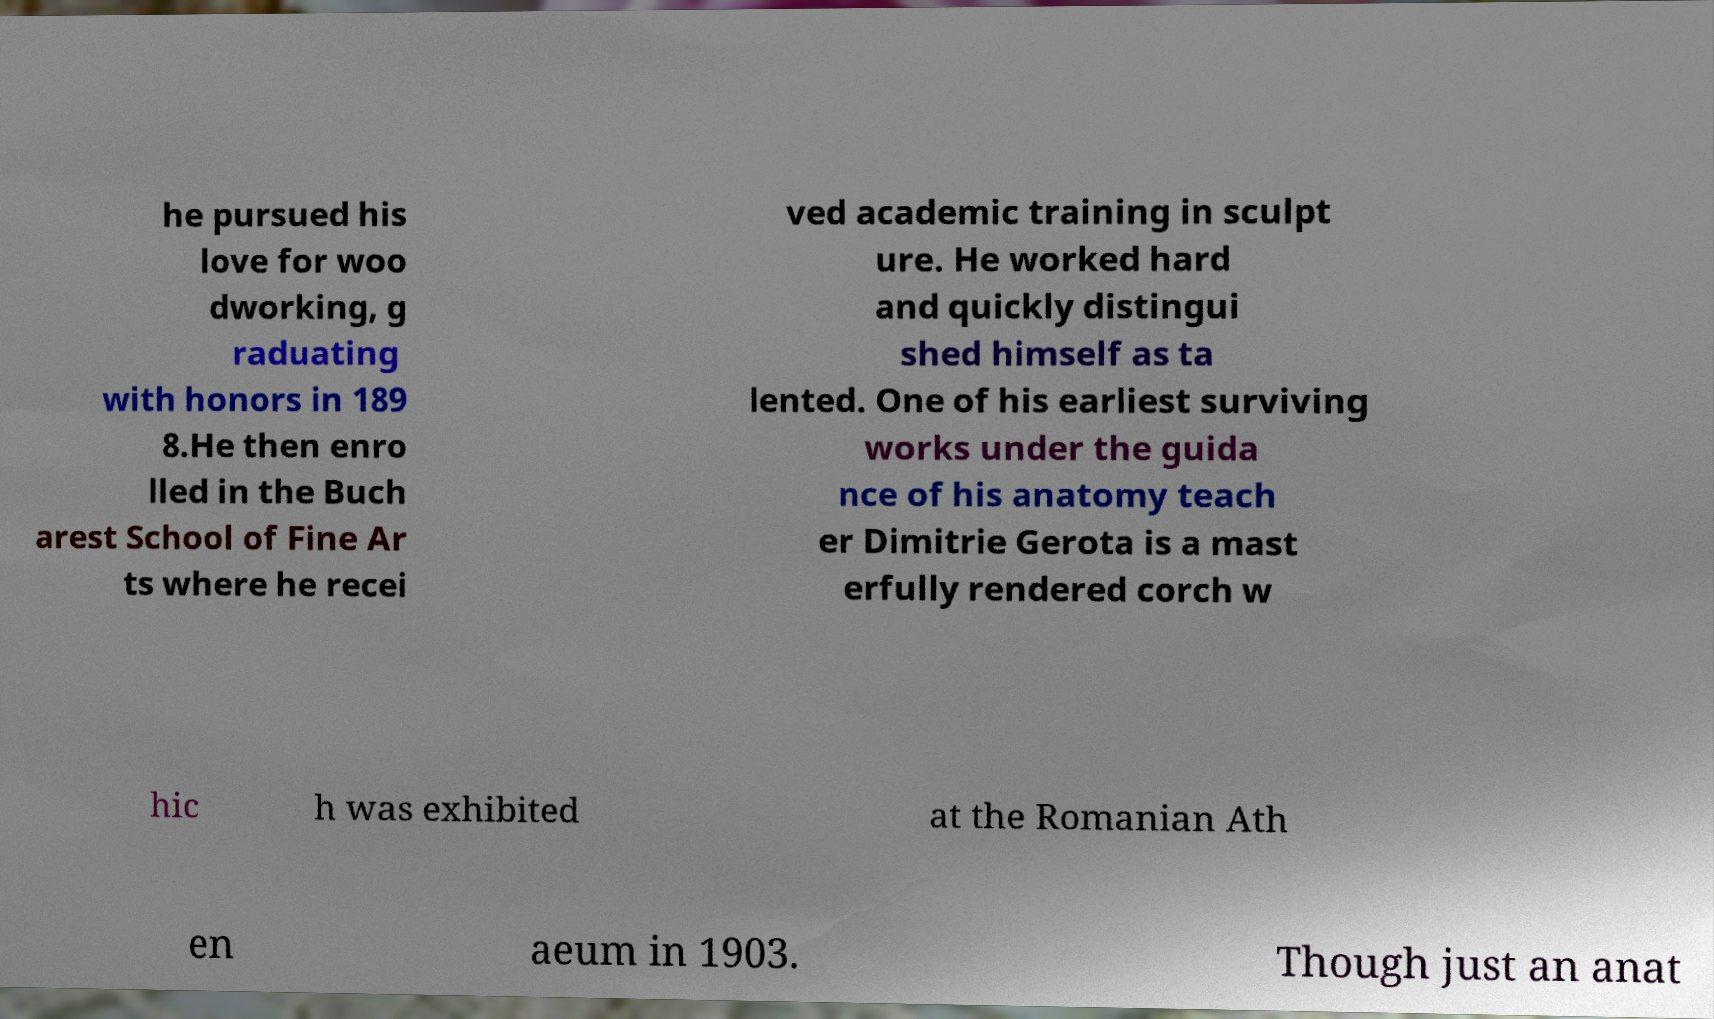Please read and relay the text visible in this image. What does it say? he pursued his love for woo dworking, g raduating with honors in 189 8.He then enro lled in the Buch arest School of Fine Ar ts where he recei ved academic training in sculpt ure. He worked hard and quickly distingui shed himself as ta lented. One of his earliest surviving works under the guida nce of his anatomy teach er Dimitrie Gerota is a mast erfully rendered corch w hic h was exhibited at the Romanian Ath en aeum in 1903. Though just an anat 